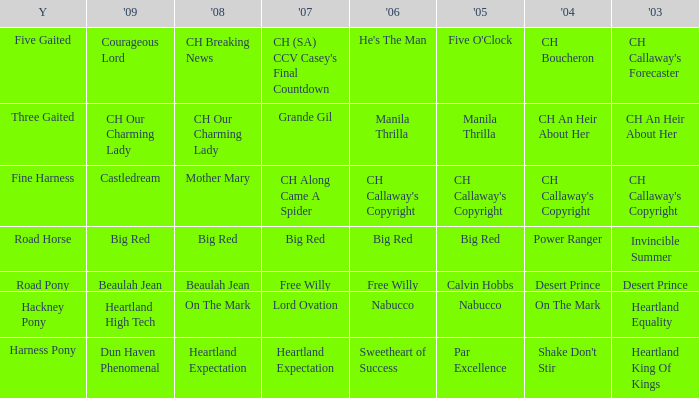What is the 2007 for the 2003 desert prince? Free Willy. 